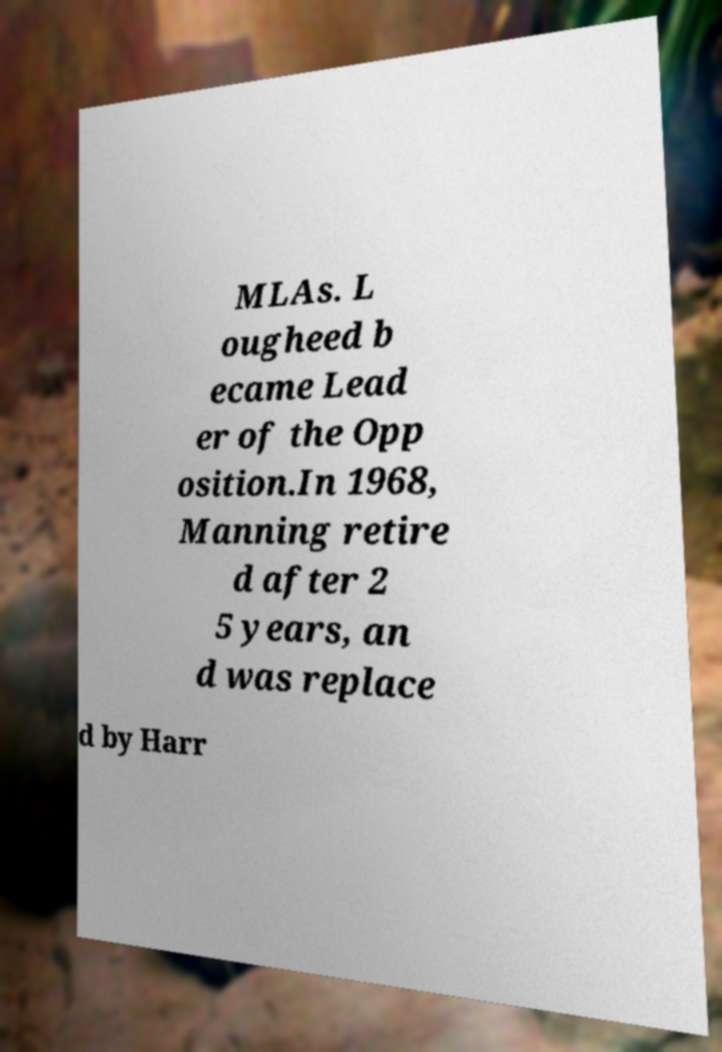There's text embedded in this image that I need extracted. Can you transcribe it verbatim? MLAs. L ougheed b ecame Lead er of the Opp osition.In 1968, Manning retire d after 2 5 years, an d was replace d by Harr 